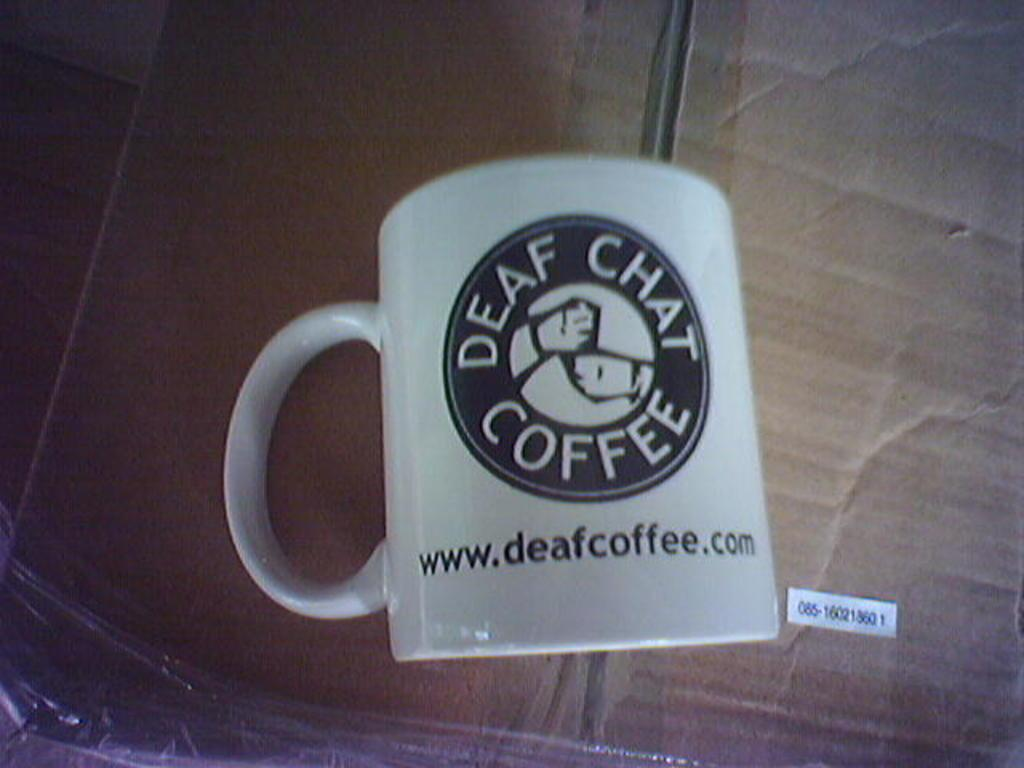Provide a one-sentence caption for the provided image. A coffee mug with the words Deaf Chat Coffee written on it. 